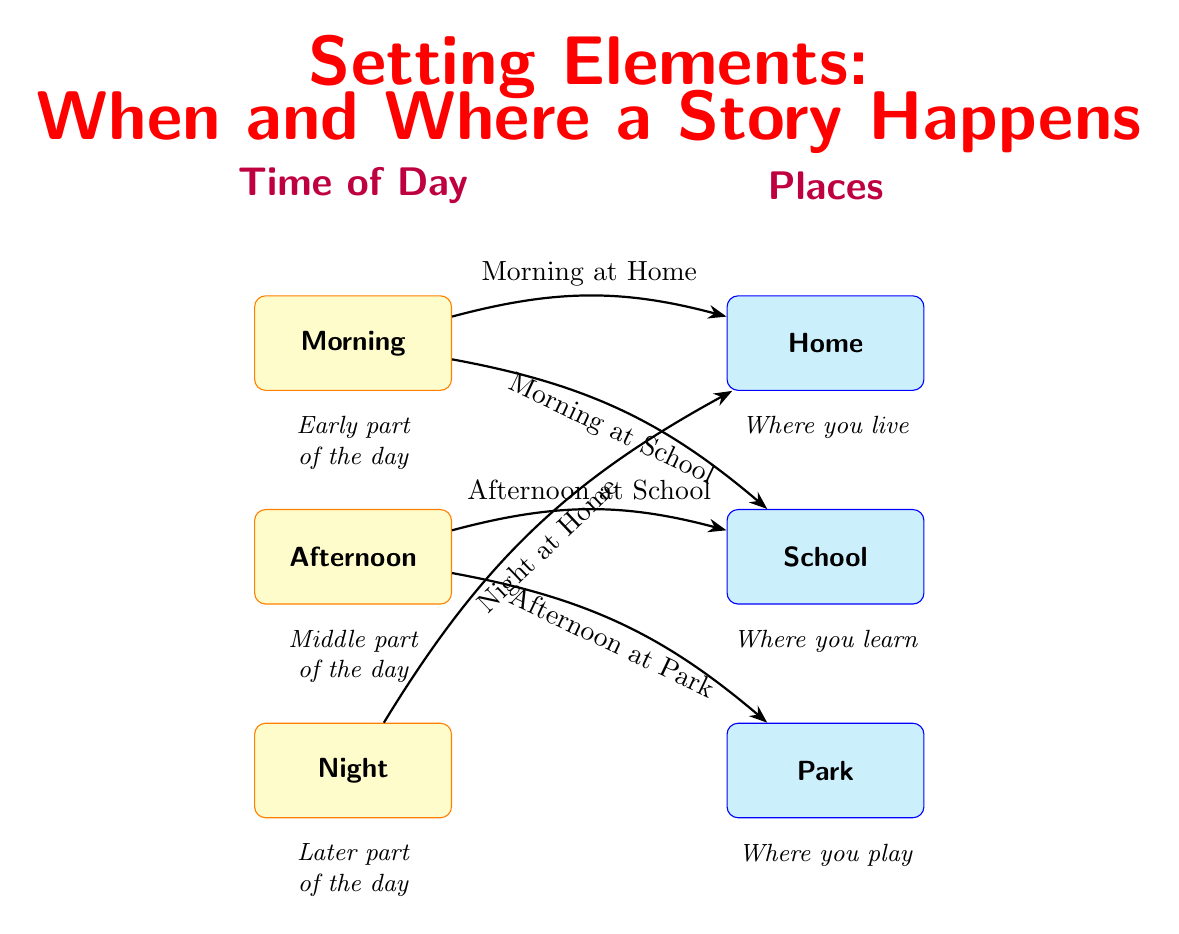What are the three times of day illustrated in the diagram? The diagram shows three specific times of day: Morning, Afternoon, and Night, which are clearly labeled in the time section.
Answer: Morning, Afternoon, Night What are the three places depicted in the diagram? The diagram depicts three distinct places: Home, School, and Park, which are also clearly labeled in the places section.
Answer: Home, School, Park How many connections are depicted in the diagram? The diagram shows a total of five connections between the time and place nodes, which can be counted from the illustrated arrows.
Answer: 5 What setting combines “Afternoon” with “Park”? The diagram includes a connection labeled "Afternoon at Park" that combines the time of afternoon with the place of the park.
Answer: Afternoon at Park What setting involves “Night” and “Home”? The diagram features a connection labeled "Night at Home," showing that these two elements are combined in a setting.
Answer: Night at Home What time is connected to “Home” twice? The diagram indicates that the time "Morning" is connected to "Home" as one setting and "Night" is connected to "Home" for another setting.
Answer: Morning and Night Which location is associated only with “School”? The connection labeled "Afternoon at School" is the only setting that exclusively associates the time of day with the school.
Answer: Afternoon at School How does the diagram describe “morning” as part of the day? The diagram describes "morning" as the "Early part of the day," indicating its position in the daily time structure.
Answer: Early part of the day What time setting is linked to both “School” and “Park”? The diagram links the time setting "Afternoon" to both "School" and "Park," indicating two distinct places associated with the same time.
Answer: Afternoon at School and Afternoon at Park 